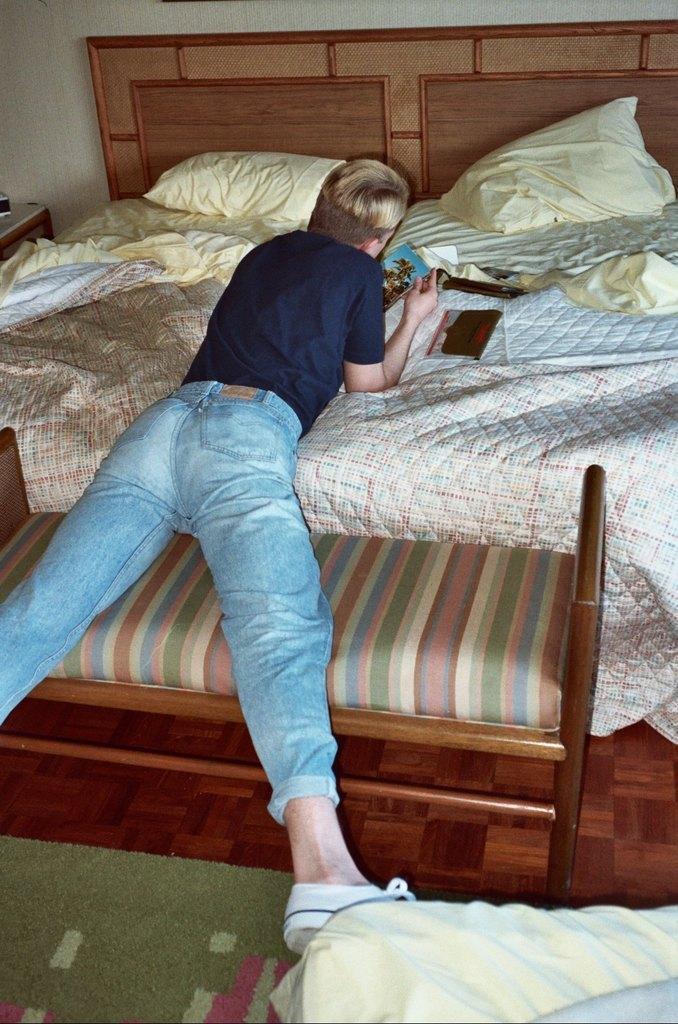Can you describe this image briefly? This is a picture taken in a room, the boy in blue t shirt was lying on a bed. On the bed there are book, remote control, pillows and bed sheet. The man is wearing a white shoe. Behind the man there is a wall and a table. 